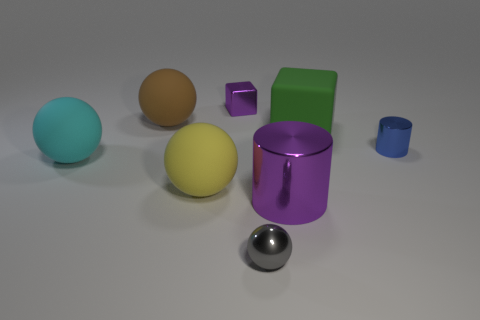Subtract all gray balls. How many balls are left? 3 Subtract all brown balls. How many balls are left? 3 Subtract all blue spheres. Subtract all gray cylinders. How many spheres are left? 4 Add 2 green blocks. How many objects exist? 10 Subtract all blocks. How many objects are left? 6 Subtract all cyan rubber cubes. Subtract all purple cylinders. How many objects are left? 7 Add 3 big green rubber blocks. How many big green rubber blocks are left? 4 Add 1 big purple metal cylinders. How many big purple metal cylinders exist? 2 Subtract 0 brown cylinders. How many objects are left? 8 